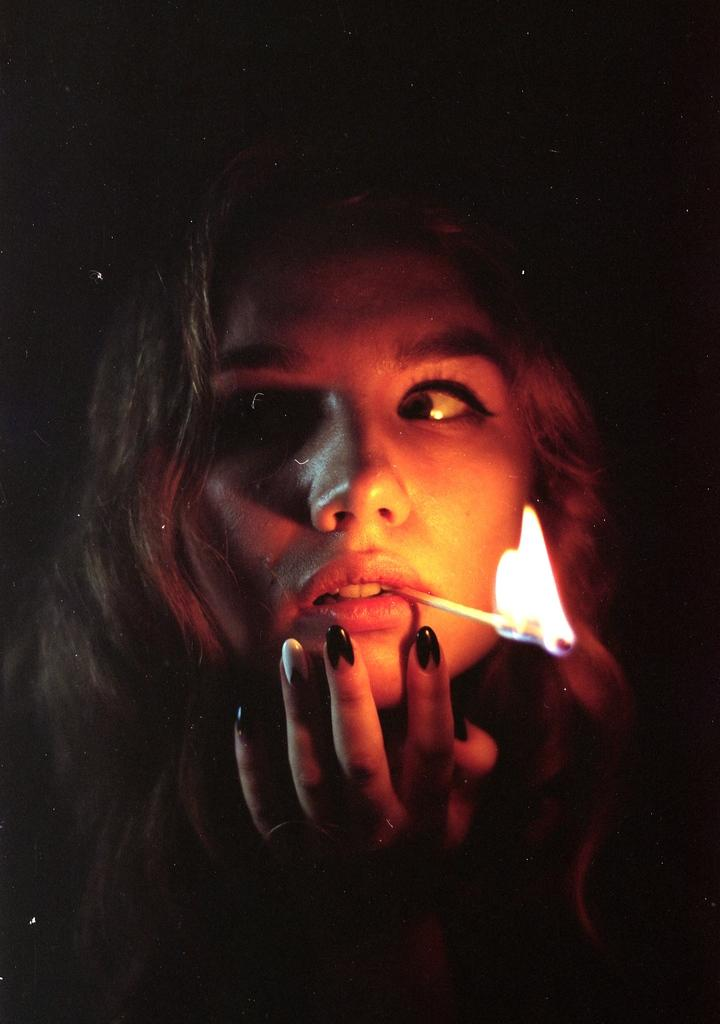Who is the main subject in the image? There is a girl in the image. What is the girl holding in her mouth? The girl has a fire stick in her mouth. Which direction is the girl looking in the image? The girl is looking to the left side of the image. What can be observed about the background of the image? The background of the image is dark. What type of machine can be seen in the aftermath of the fire in the image? There is no machine or fire present in the image; it features a girl with a fire stick in her mouth. Is there an umbrella visible in the image? No, there is no umbrella present in the image. 